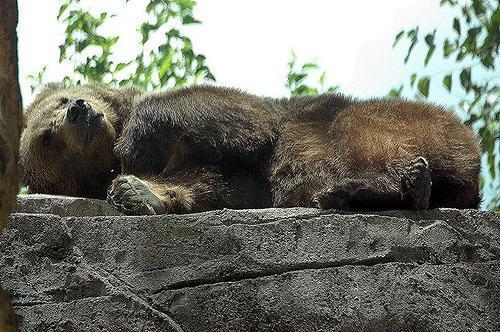How many bears are shown?
Give a very brief answer. 1. 